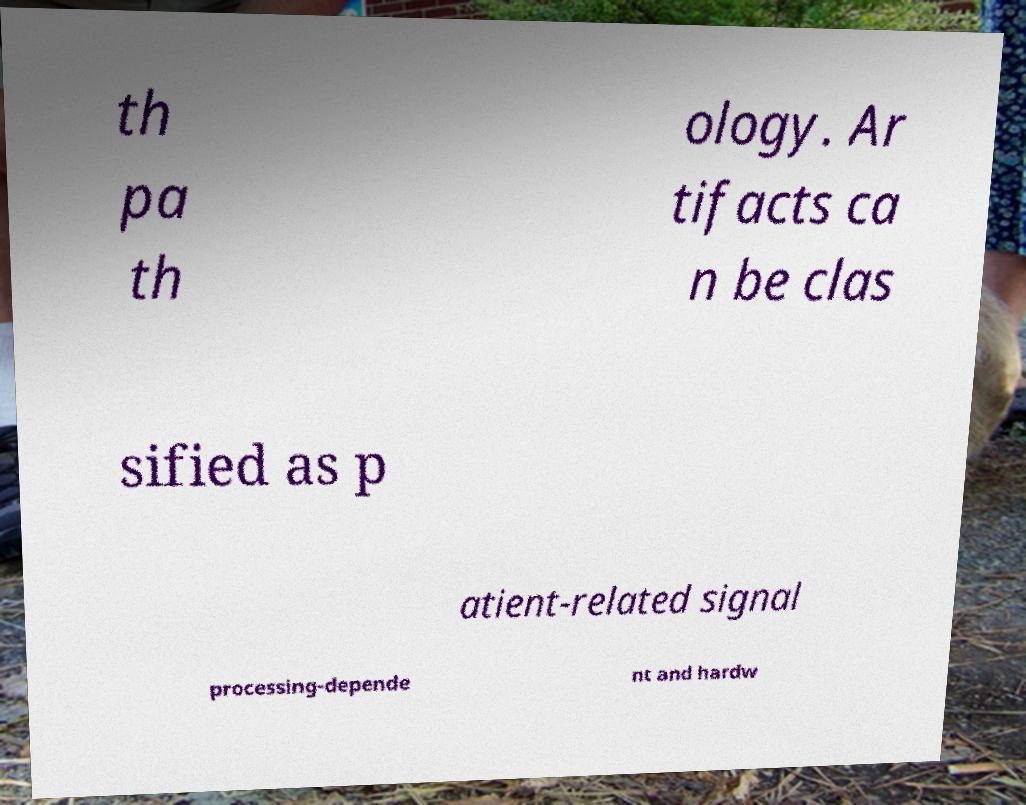There's text embedded in this image that I need extracted. Can you transcribe it verbatim? th pa th ology. Ar tifacts ca n be clas sified as p atient-related signal processing-depende nt and hardw 